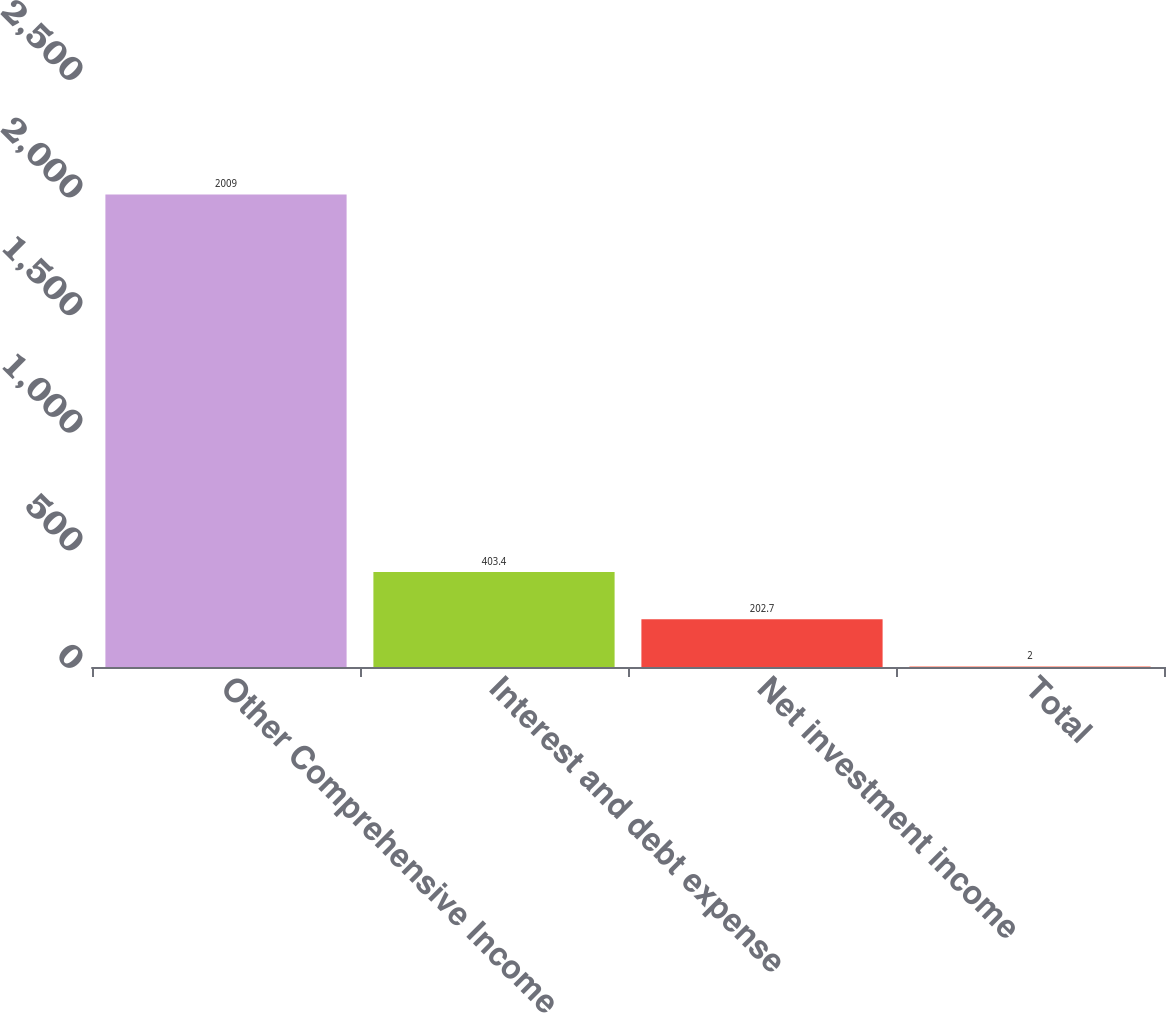Convert chart. <chart><loc_0><loc_0><loc_500><loc_500><bar_chart><fcel>Other Comprehensive Income<fcel>Interest and debt expense<fcel>Net investment income<fcel>Total<nl><fcel>2009<fcel>403.4<fcel>202.7<fcel>2<nl></chart> 